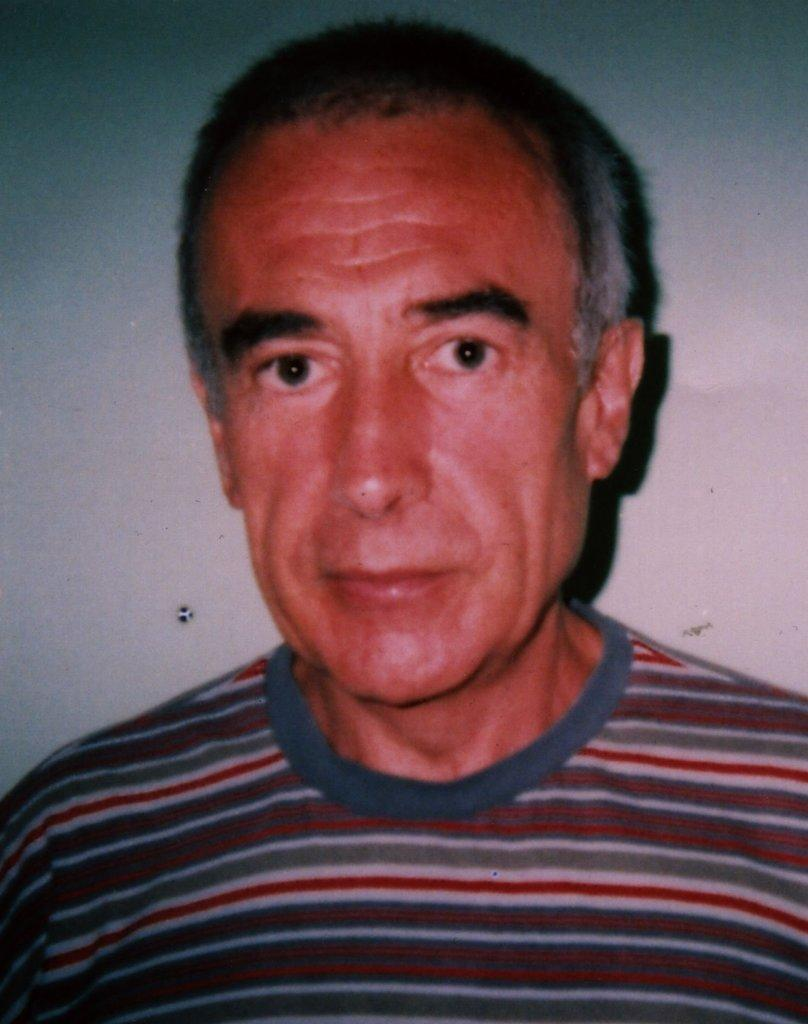Who or what is present in the image? There is a person in the image. What can be seen in the background of the image? There is a wall in the background of the image. What type of breakfast is the fireman eating in the image? There is no fireman or breakfast present in the image; it only features a person and a wall in the background. 